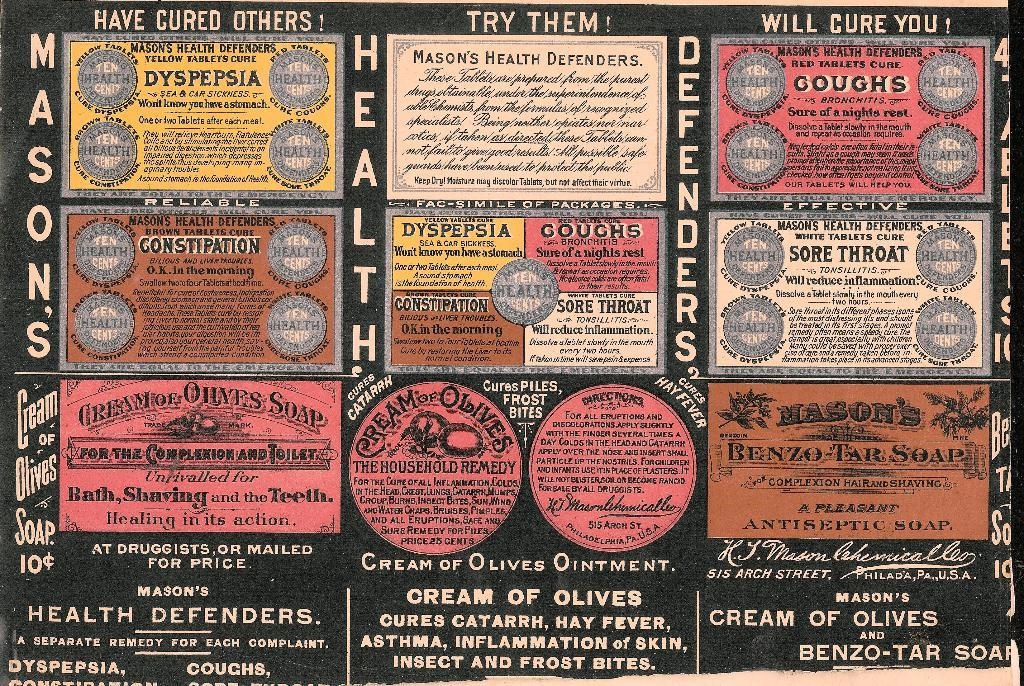<image>
Give a short and clear explanation of the subsequent image. A sign shows Mason's health defenders that says "Try Me." 